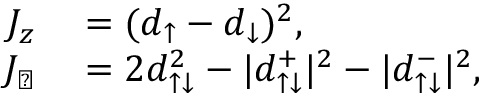Convert formula to latex. <formula><loc_0><loc_0><loc_500><loc_500>\begin{array} { r l } { J _ { z } } & = ( d _ { \uparrow } - d _ { \downarrow } ) ^ { 2 } , } \\ { J _ { \perp } } & = 2 d _ { \uparrow \downarrow } ^ { 2 } - | d _ { \uparrow \downarrow } ^ { + } | ^ { 2 } - | d _ { \uparrow \downarrow } ^ { - } | ^ { 2 } , } \end{array}</formula> 